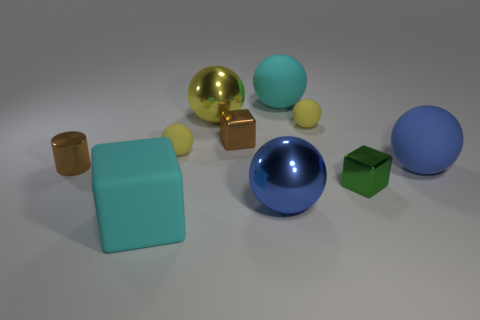Subtract all tiny brown blocks. How many blocks are left? 2 Subtract all brown cubes. How many yellow spheres are left? 3 Subtract 2 balls. How many balls are left? 4 Subtract all yellow balls. How many balls are left? 3 Subtract all red blocks. Subtract all gray balls. How many blocks are left? 3 Subtract all spheres. How many objects are left? 4 Subtract 0 purple spheres. How many objects are left? 10 Subtract all large cyan rubber balls. Subtract all yellow matte spheres. How many objects are left? 7 Add 7 brown things. How many brown things are left? 9 Add 7 cyan balls. How many cyan balls exist? 8 